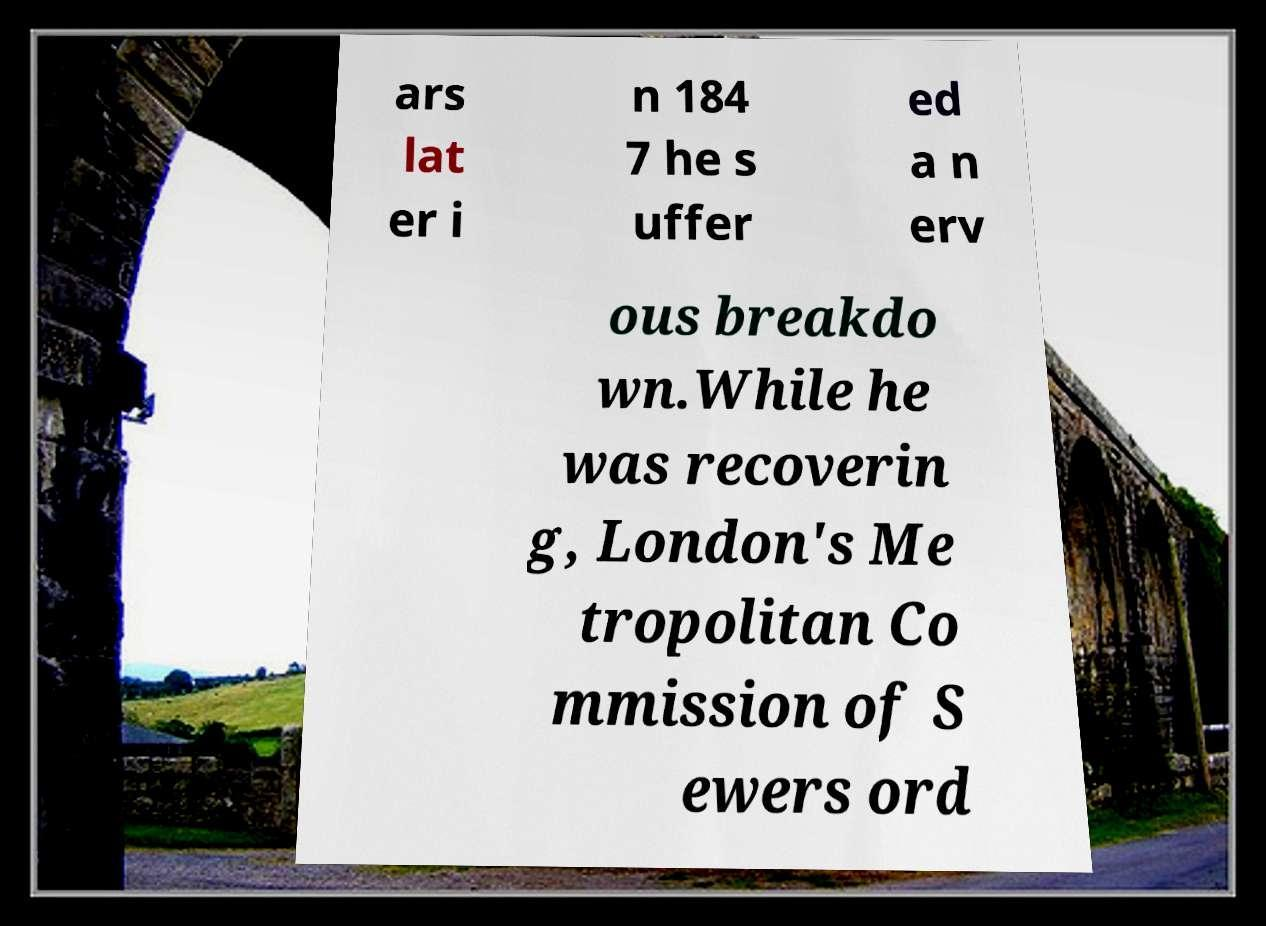Can you accurately transcribe the text from the provided image for me? ars lat er i n 184 7 he s uffer ed a n erv ous breakdo wn.While he was recoverin g, London's Me tropolitan Co mmission of S ewers ord 